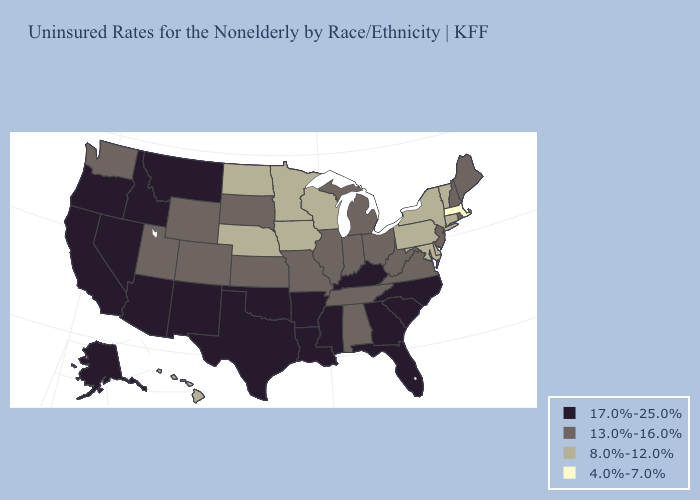Among the states that border Pennsylvania , which have the lowest value?
Quick response, please. Delaware, Maryland, New York. Does Utah have the lowest value in the West?
Answer briefly. No. What is the lowest value in states that border Ohio?
Concise answer only. 8.0%-12.0%. What is the lowest value in the USA?
Concise answer only. 4.0%-7.0%. What is the value of California?
Answer briefly. 17.0%-25.0%. What is the lowest value in states that border Virginia?
Answer briefly. 8.0%-12.0%. Name the states that have a value in the range 4.0%-7.0%?
Write a very short answer. Massachusetts. Which states have the highest value in the USA?
Be succinct. Alaska, Arizona, Arkansas, California, Florida, Georgia, Idaho, Kentucky, Louisiana, Mississippi, Montana, Nevada, New Mexico, North Carolina, Oklahoma, Oregon, South Carolina, Texas. Name the states that have a value in the range 13.0%-16.0%?
Answer briefly. Alabama, Colorado, Illinois, Indiana, Kansas, Maine, Michigan, Missouri, New Hampshire, New Jersey, Ohio, Rhode Island, South Dakota, Tennessee, Utah, Virginia, Washington, West Virginia, Wyoming. What is the value of California?
Short answer required. 17.0%-25.0%. Does Mississippi have a higher value than Oregon?
Be succinct. No. What is the value of Florida?
Quick response, please. 17.0%-25.0%. Does Minnesota have the highest value in the MidWest?
Keep it brief. No. Which states hav the highest value in the West?
Concise answer only. Alaska, Arizona, California, Idaho, Montana, Nevada, New Mexico, Oregon. Does the map have missing data?
Concise answer only. No. 